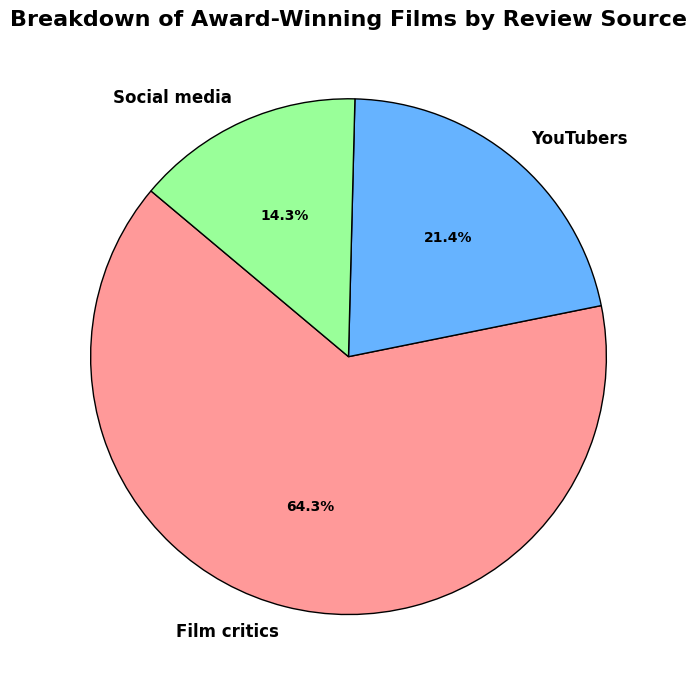What source contributed the most to award-winning films? The largest section of the pie chart is labeled "Film critics," indicating that the majority of the influential reviews came from film critics.
Answer: Film critics What percentage of the reviews come from YouTubers? The pie chart segment marked "YouTubers" shows "15%," which indicates the percentage of reviews coming from YouTubers.
Answer: 15% How does the influence of social media compare to film critics in terms of percentage? The pie chart shows that social media contributes 10% while film critics contribute 45%. Comparing these values, social media's influence (10%) is much less than that of film critics (45%).
Answer: Social media is 35% less than film critics What is the combined percentage of reviews from YouTubers and social media? The pie chart segments for YouTubers and social media show 15% and 10% respectively. Adding these together gives a total of 25%.
Answer: 25% What is the difference in the number of reviews between film critics and YouTubers? From the data, film critics have 45 reviews and YouTubers have 15. Subtracting these gives a difference of 30 reviews.
Answer: 30 Which source has the smallest share of influential reviews? The smallest segment in the pie chart is labeled "Social media," indicating it has the least share.
Answer: Social media What fraction of the total reviews come from film critics? Film critics have 45 reviews out of a total of 70 reviews (45 + 15 + 10). The fraction is 45/70, which simplifies to 9/14.
Answer: 9/14 How many more reviews does film critics have compared to the other two sources combined? Film critics have 45 reviews, YouTubers and social media combined have 25 reviews (15 + 10). The difference is 45 - 25 = 20 reviews.
Answer: 20 What is the ratio of reviews from film critics to reviews from social media? Film critics have 45 reviews and social media has 10. The ratio is 45:10, which simplifies to 9:2.
Answer: 9:2 What is the dominant color for the section representing YouTubers, and what percentage does it represent? The section for YouTubers is colored blue, according to the code, and it represents 15% of the reviews.
Answer: Blue, 15% 